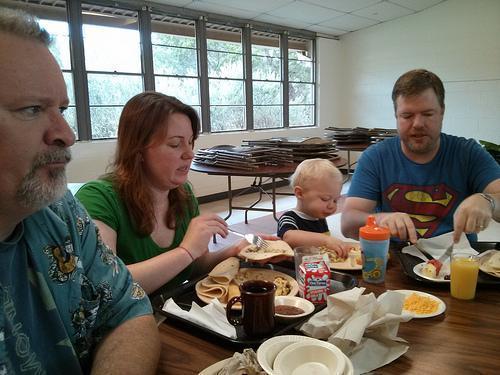How many people are in the image?
Give a very brief answer. 4. 